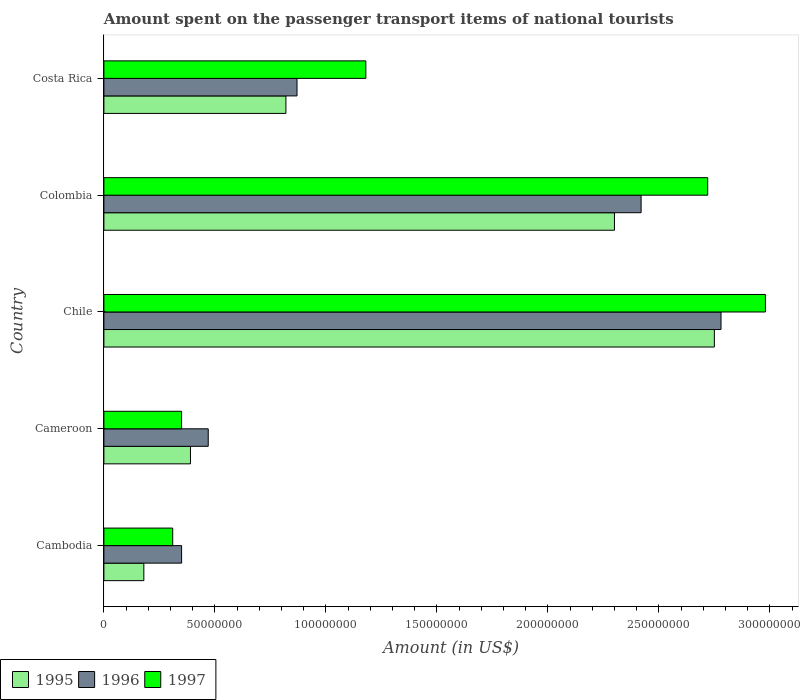How many bars are there on the 4th tick from the top?
Ensure brevity in your answer.  3. How many bars are there on the 2nd tick from the bottom?
Give a very brief answer. 3. What is the label of the 5th group of bars from the top?
Keep it short and to the point. Cambodia. What is the amount spent on the passenger transport items of national tourists in 1995 in Cambodia?
Offer a very short reply. 1.80e+07. Across all countries, what is the maximum amount spent on the passenger transport items of national tourists in 1995?
Provide a succinct answer. 2.75e+08. Across all countries, what is the minimum amount spent on the passenger transport items of national tourists in 1995?
Keep it short and to the point. 1.80e+07. In which country was the amount spent on the passenger transport items of national tourists in 1996 minimum?
Ensure brevity in your answer.  Cambodia. What is the total amount spent on the passenger transport items of national tourists in 1997 in the graph?
Offer a terse response. 7.54e+08. What is the difference between the amount spent on the passenger transport items of national tourists in 1995 in Cameroon and that in Costa Rica?
Provide a short and direct response. -4.30e+07. What is the difference between the amount spent on the passenger transport items of national tourists in 1995 in Chile and the amount spent on the passenger transport items of national tourists in 1996 in Colombia?
Make the answer very short. 3.30e+07. What is the average amount spent on the passenger transport items of national tourists in 1996 per country?
Your response must be concise. 1.38e+08. What is the difference between the amount spent on the passenger transport items of national tourists in 1996 and amount spent on the passenger transport items of national tourists in 1997 in Colombia?
Your answer should be compact. -3.00e+07. What is the ratio of the amount spent on the passenger transport items of national tourists in 1997 in Chile to that in Colombia?
Provide a succinct answer. 1.1. Is the amount spent on the passenger transport items of national tourists in 1996 in Chile less than that in Colombia?
Give a very brief answer. No. Is the difference between the amount spent on the passenger transport items of national tourists in 1996 in Colombia and Costa Rica greater than the difference between the amount spent on the passenger transport items of national tourists in 1997 in Colombia and Costa Rica?
Ensure brevity in your answer.  Yes. What is the difference between the highest and the second highest amount spent on the passenger transport items of national tourists in 1997?
Your response must be concise. 2.60e+07. What is the difference between the highest and the lowest amount spent on the passenger transport items of national tourists in 1997?
Your answer should be very brief. 2.67e+08. Is the sum of the amount spent on the passenger transport items of national tourists in 1996 in Cameroon and Colombia greater than the maximum amount spent on the passenger transport items of national tourists in 1997 across all countries?
Give a very brief answer. No. Is it the case that in every country, the sum of the amount spent on the passenger transport items of national tourists in 1997 and amount spent on the passenger transport items of national tourists in 1995 is greater than the amount spent on the passenger transport items of national tourists in 1996?
Give a very brief answer. Yes. How many bars are there?
Make the answer very short. 15. Are all the bars in the graph horizontal?
Ensure brevity in your answer.  Yes. Are the values on the major ticks of X-axis written in scientific E-notation?
Your answer should be very brief. No. Does the graph contain any zero values?
Offer a very short reply. No. How are the legend labels stacked?
Provide a succinct answer. Horizontal. What is the title of the graph?
Offer a terse response. Amount spent on the passenger transport items of national tourists. Does "2011" appear as one of the legend labels in the graph?
Ensure brevity in your answer.  No. What is the label or title of the Y-axis?
Your answer should be compact. Country. What is the Amount (in US$) of 1995 in Cambodia?
Your response must be concise. 1.80e+07. What is the Amount (in US$) in 1996 in Cambodia?
Make the answer very short. 3.50e+07. What is the Amount (in US$) in 1997 in Cambodia?
Your answer should be compact. 3.10e+07. What is the Amount (in US$) in 1995 in Cameroon?
Give a very brief answer. 3.90e+07. What is the Amount (in US$) of 1996 in Cameroon?
Ensure brevity in your answer.  4.70e+07. What is the Amount (in US$) in 1997 in Cameroon?
Offer a very short reply. 3.50e+07. What is the Amount (in US$) of 1995 in Chile?
Provide a short and direct response. 2.75e+08. What is the Amount (in US$) of 1996 in Chile?
Offer a terse response. 2.78e+08. What is the Amount (in US$) in 1997 in Chile?
Give a very brief answer. 2.98e+08. What is the Amount (in US$) in 1995 in Colombia?
Give a very brief answer. 2.30e+08. What is the Amount (in US$) in 1996 in Colombia?
Provide a short and direct response. 2.42e+08. What is the Amount (in US$) of 1997 in Colombia?
Provide a succinct answer. 2.72e+08. What is the Amount (in US$) in 1995 in Costa Rica?
Offer a very short reply. 8.20e+07. What is the Amount (in US$) in 1996 in Costa Rica?
Offer a very short reply. 8.70e+07. What is the Amount (in US$) in 1997 in Costa Rica?
Your answer should be very brief. 1.18e+08. Across all countries, what is the maximum Amount (in US$) of 1995?
Keep it short and to the point. 2.75e+08. Across all countries, what is the maximum Amount (in US$) of 1996?
Your response must be concise. 2.78e+08. Across all countries, what is the maximum Amount (in US$) in 1997?
Provide a short and direct response. 2.98e+08. Across all countries, what is the minimum Amount (in US$) in 1995?
Your answer should be very brief. 1.80e+07. Across all countries, what is the minimum Amount (in US$) in 1996?
Make the answer very short. 3.50e+07. Across all countries, what is the minimum Amount (in US$) of 1997?
Ensure brevity in your answer.  3.10e+07. What is the total Amount (in US$) of 1995 in the graph?
Provide a succinct answer. 6.44e+08. What is the total Amount (in US$) of 1996 in the graph?
Provide a succinct answer. 6.89e+08. What is the total Amount (in US$) of 1997 in the graph?
Ensure brevity in your answer.  7.54e+08. What is the difference between the Amount (in US$) in 1995 in Cambodia and that in Cameroon?
Offer a terse response. -2.10e+07. What is the difference between the Amount (in US$) in 1996 in Cambodia and that in Cameroon?
Provide a succinct answer. -1.20e+07. What is the difference between the Amount (in US$) in 1997 in Cambodia and that in Cameroon?
Your answer should be compact. -4.00e+06. What is the difference between the Amount (in US$) of 1995 in Cambodia and that in Chile?
Your answer should be very brief. -2.57e+08. What is the difference between the Amount (in US$) in 1996 in Cambodia and that in Chile?
Give a very brief answer. -2.43e+08. What is the difference between the Amount (in US$) in 1997 in Cambodia and that in Chile?
Offer a very short reply. -2.67e+08. What is the difference between the Amount (in US$) in 1995 in Cambodia and that in Colombia?
Keep it short and to the point. -2.12e+08. What is the difference between the Amount (in US$) of 1996 in Cambodia and that in Colombia?
Keep it short and to the point. -2.07e+08. What is the difference between the Amount (in US$) of 1997 in Cambodia and that in Colombia?
Make the answer very short. -2.41e+08. What is the difference between the Amount (in US$) in 1995 in Cambodia and that in Costa Rica?
Give a very brief answer. -6.40e+07. What is the difference between the Amount (in US$) of 1996 in Cambodia and that in Costa Rica?
Provide a succinct answer. -5.20e+07. What is the difference between the Amount (in US$) of 1997 in Cambodia and that in Costa Rica?
Offer a terse response. -8.70e+07. What is the difference between the Amount (in US$) of 1995 in Cameroon and that in Chile?
Offer a terse response. -2.36e+08. What is the difference between the Amount (in US$) in 1996 in Cameroon and that in Chile?
Provide a short and direct response. -2.31e+08. What is the difference between the Amount (in US$) of 1997 in Cameroon and that in Chile?
Ensure brevity in your answer.  -2.63e+08. What is the difference between the Amount (in US$) of 1995 in Cameroon and that in Colombia?
Offer a very short reply. -1.91e+08. What is the difference between the Amount (in US$) in 1996 in Cameroon and that in Colombia?
Your answer should be very brief. -1.95e+08. What is the difference between the Amount (in US$) in 1997 in Cameroon and that in Colombia?
Keep it short and to the point. -2.37e+08. What is the difference between the Amount (in US$) in 1995 in Cameroon and that in Costa Rica?
Provide a short and direct response. -4.30e+07. What is the difference between the Amount (in US$) in 1996 in Cameroon and that in Costa Rica?
Offer a very short reply. -4.00e+07. What is the difference between the Amount (in US$) in 1997 in Cameroon and that in Costa Rica?
Provide a succinct answer. -8.30e+07. What is the difference between the Amount (in US$) of 1995 in Chile and that in Colombia?
Provide a short and direct response. 4.50e+07. What is the difference between the Amount (in US$) in 1996 in Chile and that in Colombia?
Provide a short and direct response. 3.60e+07. What is the difference between the Amount (in US$) in 1997 in Chile and that in Colombia?
Your response must be concise. 2.60e+07. What is the difference between the Amount (in US$) of 1995 in Chile and that in Costa Rica?
Make the answer very short. 1.93e+08. What is the difference between the Amount (in US$) in 1996 in Chile and that in Costa Rica?
Ensure brevity in your answer.  1.91e+08. What is the difference between the Amount (in US$) in 1997 in Chile and that in Costa Rica?
Make the answer very short. 1.80e+08. What is the difference between the Amount (in US$) in 1995 in Colombia and that in Costa Rica?
Offer a terse response. 1.48e+08. What is the difference between the Amount (in US$) in 1996 in Colombia and that in Costa Rica?
Provide a succinct answer. 1.55e+08. What is the difference between the Amount (in US$) in 1997 in Colombia and that in Costa Rica?
Provide a succinct answer. 1.54e+08. What is the difference between the Amount (in US$) in 1995 in Cambodia and the Amount (in US$) in 1996 in Cameroon?
Keep it short and to the point. -2.90e+07. What is the difference between the Amount (in US$) in 1995 in Cambodia and the Amount (in US$) in 1997 in Cameroon?
Ensure brevity in your answer.  -1.70e+07. What is the difference between the Amount (in US$) of 1996 in Cambodia and the Amount (in US$) of 1997 in Cameroon?
Make the answer very short. 0. What is the difference between the Amount (in US$) of 1995 in Cambodia and the Amount (in US$) of 1996 in Chile?
Your answer should be very brief. -2.60e+08. What is the difference between the Amount (in US$) in 1995 in Cambodia and the Amount (in US$) in 1997 in Chile?
Offer a terse response. -2.80e+08. What is the difference between the Amount (in US$) in 1996 in Cambodia and the Amount (in US$) in 1997 in Chile?
Provide a succinct answer. -2.63e+08. What is the difference between the Amount (in US$) of 1995 in Cambodia and the Amount (in US$) of 1996 in Colombia?
Provide a short and direct response. -2.24e+08. What is the difference between the Amount (in US$) of 1995 in Cambodia and the Amount (in US$) of 1997 in Colombia?
Provide a short and direct response. -2.54e+08. What is the difference between the Amount (in US$) in 1996 in Cambodia and the Amount (in US$) in 1997 in Colombia?
Provide a succinct answer. -2.37e+08. What is the difference between the Amount (in US$) in 1995 in Cambodia and the Amount (in US$) in 1996 in Costa Rica?
Offer a terse response. -6.90e+07. What is the difference between the Amount (in US$) of 1995 in Cambodia and the Amount (in US$) of 1997 in Costa Rica?
Offer a very short reply. -1.00e+08. What is the difference between the Amount (in US$) in 1996 in Cambodia and the Amount (in US$) in 1997 in Costa Rica?
Give a very brief answer. -8.30e+07. What is the difference between the Amount (in US$) in 1995 in Cameroon and the Amount (in US$) in 1996 in Chile?
Your response must be concise. -2.39e+08. What is the difference between the Amount (in US$) in 1995 in Cameroon and the Amount (in US$) in 1997 in Chile?
Make the answer very short. -2.59e+08. What is the difference between the Amount (in US$) in 1996 in Cameroon and the Amount (in US$) in 1997 in Chile?
Offer a terse response. -2.51e+08. What is the difference between the Amount (in US$) in 1995 in Cameroon and the Amount (in US$) in 1996 in Colombia?
Keep it short and to the point. -2.03e+08. What is the difference between the Amount (in US$) in 1995 in Cameroon and the Amount (in US$) in 1997 in Colombia?
Make the answer very short. -2.33e+08. What is the difference between the Amount (in US$) of 1996 in Cameroon and the Amount (in US$) of 1997 in Colombia?
Your response must be concise. -2.25e+08. What is the difference between the Amount (in US$) of 1995 in Cameroon and the Amount (in US$) of 1996 in Costa Rica?
Your response must be concise. -4.80e+07. What is the difference between the Amount (in US$) in 1995 in Cameroon and the Amount (in US$) in 1997 in Costa Rica?
Provide a short and direct response. -7.90e+07. What is the difference between the Amount (in US$) of 1996 in Cameroon and the Amount (in US$) of 1997 in Costa Rica?
Make the answer very short. -7.10e+07. What is the difference between the Amount (in US$) of 1995 in Chile and the Amount (in US$) of 1996 in Colombia?
Make the answer very short. 3.30e+07. What is the difference between the Amount (in US$) of 1995 in Chile and the Amount (in US$) of 1996 in Costa Rica?
Provide a short and direct response. 1.88e+08. What is the difference between the Amount (in US$) in 1995 in Chile and the Amount (in US$) in 1997 in Costa Rica?
Provide a short and direct response. 1.57e+08. What is the difference between the Amount (in US$) of 1996 in Chile and the Amount (in US$) of 1997 in Costa Rica?
Ensure brevity in your answer.  1.60e+08. What is the difference between the Amount (in US$) of 1995 in Colombia and the Amount (in US$) of 1996 in Costa Rica?
Offer a very short reply. 1.43e+08. What is the difference between the Amount (in US$) of 1995 in Colombia and the Amount (in US$) of 1997 in Costa Rica?
Give a very brief answer. 1.12e+08. What is the difference between the Amount (in US$) in 1996 in Colombia and the Amount (in US$) in 1997 in Costa Rica?
Give a very brief answer. 1.24e+08. What is the average Amount (in US$) in 1995 per country?
Offer a terse response. 1.29e+08. What is the average Amount (in US$) of 1996 per country?
Your answer should be very brief. 1.38e+08. What is the average Amount (in US$) of 1997 per country?
Provide a succinct answer. 1.51e+08. What is the difference between the Amount (in US$) of 1995 and Amount (in US$) of 1996 in Cambodia?
Give a very brief answer. -1.70e+07. What is the difference between the Amount (in US$) in 1995 and Amount (in US$) in 1997 in Cambodia?
Make the answer very short. -1.30e+07. What is the difference between the Amount (in US$) of 1995 and Amount (in US$) of 1996 in Cameroon?
Give a very brief answer. -8.00e+06. What is the difference between the Amount (in US$) in 1995 and Amount (in US$) in 1997 in Cameroon?
Provide a succinct answer. 4.00e+06. What is the difference between the Amount (in US$) in 1996 and Amount (in US$) in 1997 in Cameroon?
Your response must be concise. 1.20e+07. What is the difference between the Amount (in US$) in 1995 and Amount (in US$) in 1996 in Chile?
Ensure brevity in your answer.  -3.00e+06. What is the difference between the Amount (in US$) of 1995 and Amount (in US$) of 1997 in Chile?
Make the answer very short. -2.30e+07. What is the difference between the Amount (in US$) of 1996 and Amount (in US$) of 1997 in Chile?
Provide a short and direct response. -2.00e+07. What is the difference between the Amount (in US$) of 1995 and Amount (in US$) of 1996 in Colombia?
Offer a very short reply. -1.20e+07. What is the difference between the Amount (in US$) of 1995 and Amount (in US$) of 1997 in Colombia?
Provide a succinct answer. -4.20e+07. What is the difference between the Amount (in US$) of 1996 and Amount (in US$) of 1997 in Colombia?
Ensure brevity in your answer.  -3.00e+07. What is the difference between the Amount (in US$) in 1995 and Amount (in US$) in 1996 in Costa Rica?
Keep it short and to the point. -5.00e+06. What is the difference between the Amount (in US$) of 1995 and Amount (in US$) of 1997 in Costa Rica?
Provide a short and direct response. -3.60e+07. What is the difference between the Amount (in US$) in 1996 and Amount (in US$) in 1997 in Costa Rica?
Keep it short and to the point. -3.10e+07. What is the ratio of the Amount (in US$) of 1995 in Cambodia to that in Cameroon?
Offer a very short reply. 0.46. What is the ratio of the Amount (in US$) of 1996 in Cambodia to that in Cameroon?
Give a very brief answer. 0.74. What is the ratio of the Amount (in US$) of 1997 in Cambodia to that in Cameroon?
Offer a very short reply. 0.89. What is the ratio of the Amount (in US$) in 1995 in Cambodia to that in Chile?
Provide a succinct answer. 0.07. What is the ratio of the Amount (in US$) of 1996 in Cambodia to that in Chile?
Keep it short and to the point. 0.13. What is the ratio of the Amount (in US$) in 1997 in Cambodia to that in Chile?
Ensure brevity in your answer.  0.1. What is the ratio of the Amount (in US$) in 1995 in Cambodia to that in Colombia?
Give a very brief answer. 0.08. What is the ratio of the Amount (in US$) of 1996 in Cambodia to that in Colombia?
Provide a short and direct response. 0.14. What is the ratio of the Amount (in US$) of 1997 in Cambodia to that in Colombia?
Provide a succinct answer. 0.11. What is the ratio of the Amount (in US$) in 1995 in Cambodia to that in Costa Rica?
Your answer should be very brief. 0.22. What is the ratio of the Amount (in US$) in 1996 in Cambodia to that in Costa Rica?
Your answer should be very brief. 0.4. What is the ratio of the Amount (in US$) in 1997 in Cambodia to that in Costa Rica?
Offer a very short reply. 0.26. What is the ratio of the Amount (in US$) of 1995 in Cameroon to that in Chile?
Your answer should be compact. 0.14. What is the ratio of the Amount (in US$) of 1996 in Cameroon to that in Chile?
Provide a short and direct response. 0.17. What is the ratio of the Amount (in US$) in 1997 in Cameroon to that in Chile?
Give a very brief answer. 0.12. What is the ratio of the Amount (in US$) of 1995 in Cameroon to that in Colombia?
Your answer should be compact. 0.17. What is the ratio of the Amount (in US$) in 1996 in Cameroon to that in Colombia?
Provide a succinct answer. 0.19. What is the ratio of the Amount (in US$) of 1997 in Cameroon to that in Colombia?
Give a very brief answer. 0.13. What is the ratio of the Amount (in US$) of 1995 in Cameroon to that in Costa Rica?
Offer a terse response. 0.48. What is the ratio of the Amount (in US$) of 1996 in Cameroon to that in Costa Rica?
Keep it short and to the point. 0.54. What is the ratio of the Amount (in US$) of 1997 in Cameroon to that in Costa Rica?
Offer a terse response. 0.3. What is the ratio of the Amount (in US$) in 1995 in Chile to that in Colombia?
Keep it short and to the point. 1.2. What is the ratio of the Amount (in US$) of 1996 in Chile to that in Colombia?
Give a very brief answer. 1.15. What is the ratio of the Amount (in US$) in 1997 in Chile to that in Colombia?
Offer a terse response. 1.1. What is the ratio of the Amount (in US$) in 1995 in Chile to that in Costa Rica?
Your response must be concise. 3.35. What is the ratio of the Amount (in US$) in 1996 in Chile to that in Costa Rica?
Make the answer very short. 3.2. What is the ratio of the Amount (in US$) in 1997 in Chile to that in Costa Rica?
Offer a terse response. 2.53. What is the ratio of the Amount (in US$) in 1995 in Colombia to that in Costa Rica?
Ensure brevity in your answer.  2.8. What is the ratio of the Amount (in US$) in 1996 in Colombia to that in Costa Rica?
Provide a short and direct response. 2.78. What is the ratio of the Amount (in US$) of 1997 in Colombia to that in Costa Rica?
Keep it short and to the point. 2.31. What is the difference between the highest and the second highest Amount (in US$) in 1995?
Your answer should be compact. 4.50e+07. What is the difference between the highest and the second highest Amount (in US$) in 1996?
Provide a succinct answer. 3.60e+07. What is the difference between the highest and the second highest Amount (in US$) of 1997?
Your answer should be compact. 2.60e+07. What is the difference between the highest and the lowest Amount (in US$) of 1995?
Provide a short and direct response. 2.57e+08. What is the difference between the highest and the lowest Amount (in US$) of 1996?
Offer a terse response. 2.43e+08. What is the difference between the highest and the lowest Amount (in US$) in 1997?
Make the answer very short. 2.67e+08. 